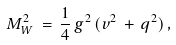<formula> <loc_0><loc_0><loc_500><loc_500>M ^ { 2 } _ { W } \, = \, \frac { 1 } { 4 } \, g ^ { 2 } \, ( v ^ { 2 } \, + \, q ^ { 2 } ) \, ,</formula> 